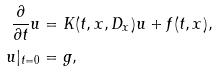<formula> <loc_0><loc_0><loc_500><loc_500>\frac { \partial } { \partial t } u & = K ( t , x , D _ { x } ) u + f ( t , x ) , \\ u | _ { t = 0 } & = g ,</formula> 